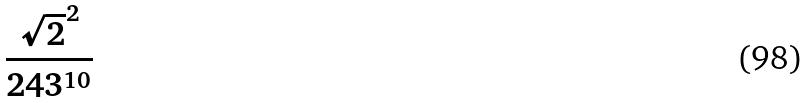<formula> <loc_0><loc_0><loc_500><loc_500>\frac { \sqrt { 2 } ^ { 2 } } { 2 4 3 ^ { 1 0 } }</formula> 